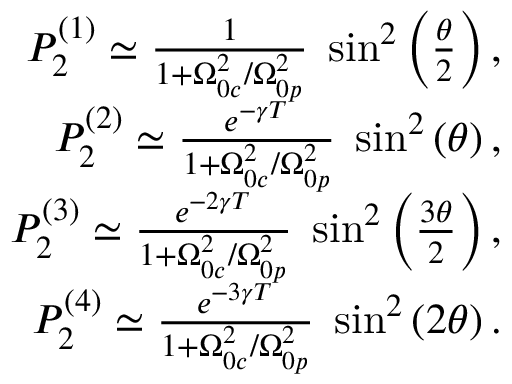Convert formula to latex. <formula><loc_0><loc_0><loc_500><loc_500>\begin{array} { r l r } & { P _ { 2 } ^ { ( 1 ) } \simeq \frac { 1 } { 1 + \Omega _ { 0 c } ^ { 2 } / \Omega _ { 0 p } ^ { 2 } } \, \sin ^ { 2 } \left ( \frac { \theta } { 2 } \right ) , } \\ & { P _ { 2 } ^ { ( 2 ) } \simeq \frac { e ^ { - \gamma T } } { 1 + \Omega _ { 0 c } ^ { 2 } / \Omega _ { 0 p } ^ { 2 } } \, \sin ^ { 2 } \left ( \theta \right ) , } \\ & { P _ { 2 } ^ { ( 3 ) } \simeq \frac { e ^ { - 2 \gamma T } } { 1 + \Omega _ { 0 c } ^ { 2 } / \Omega _ { 0 p } ^ { 2 } } \, \sin ^ { 2 } \left ( \frac { 3 \theta } { 2 } \right ) , } \\ & { P _ { 2 } ^ { ( 4 ) } \simeq \frac { e ^ { - 3 \gamma T } } { 1 + \Omega _ { 0 c } ^ { 2 } / \Omega _ { 0 p } ^ { 2 } } \, \sin ^ { 2 } \left ( 2 \theta \right ) . } \end{array}</formula> 